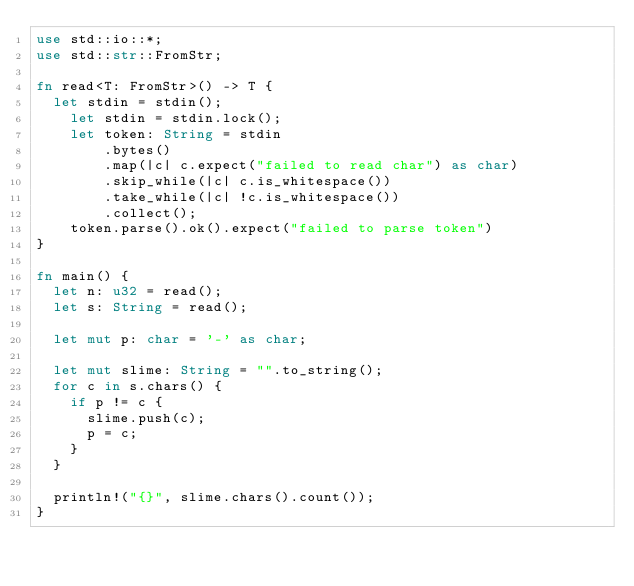<code> <loc_0><loc_0><loc_500><loc_500><_Rust_>use std::io::*;
use std::str::FromStr;
   
fn read<T: FromStr>() -> T {
	let stdin = stdin();
    let stdin = stdin.lock();
    let token: String = stdin
        .bytes()
        .map(|c| c.expect("failed to read char") as char)
        .skip_while(|c| c.is_whitespace())
        .take_while(|c| !c.is_whitespace())
        .collect();
    token.parse().ok().expect("failed to parse token")
}

fn main() {
	let n: u32 = read();
	let s: String = read();

	let mut p: char = '-' as char;

	let mut slime: String = "".to_string();
	for c in s.chars() {
		if p != c {
			slime.push(c);
			p = c;
		}
	}

	println!("{}", slime.chars().count());
}</code> 